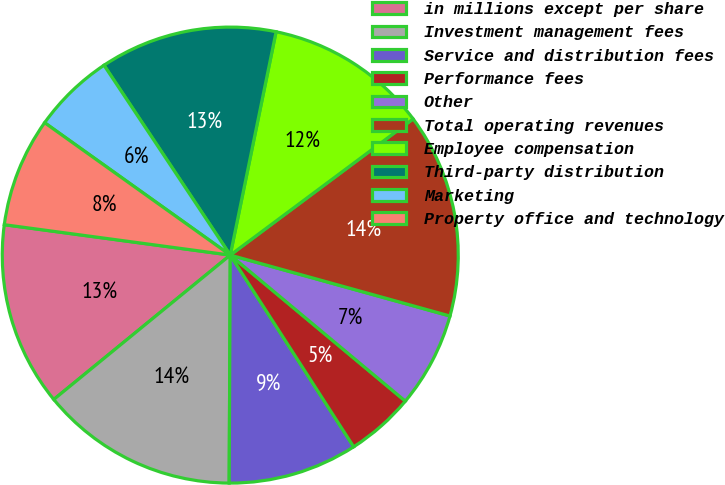<chart> <loc_0><loc_0><loc_500><loc_500><pie_chart><fcel>in millions except per share<fcel>Investment management fees<fcel>Service and distribution fees<fcel>Performance fees<fcel>Other<fcel>Total operating revenues<fcel>Employee compensation<fcel>Third-party distribution<fcel>Marketing<fcel>Property office and technology<nl><fcel>13.04%<fcel>14.01%<fcel>9.18%<fcel>4.83%<fcel>6.76%<fcel>14.49%<fcel>11.59%<fcel>12.56%<fcel>5.8%<fcel>7.73%<nl></chart> 